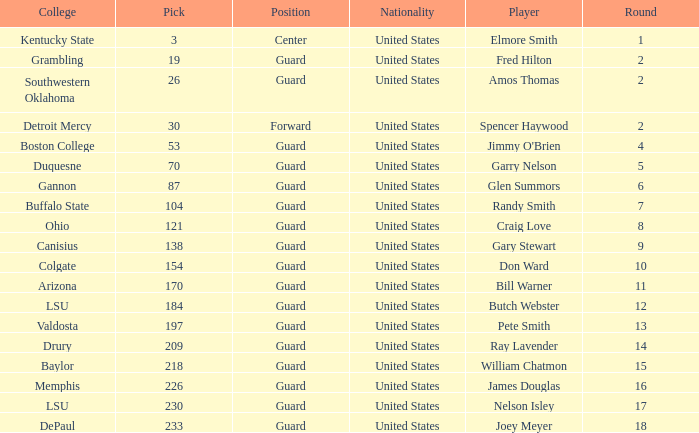WHAT IS THE TOTAL PICK FOR BOSTON COLLEGE? 1.0. 